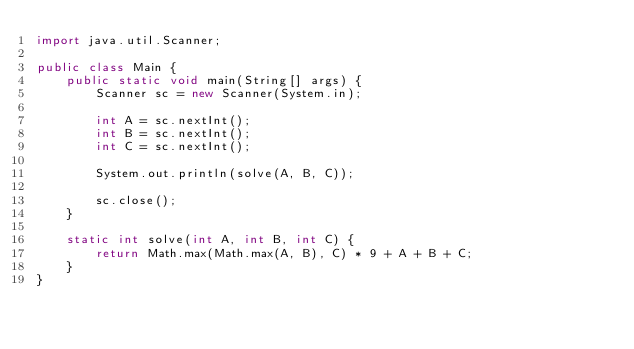Convert code to text. <code><loc_0><loc_0><loc_500><loc_500><_Java_>import java.util.Scanner;

public class Main {
    public static void main(String[] args) {
        Scanner sc = new Scanner(System.in);

        int A = sc.nextInt();
        int B = sc.nextInt();
        int C = sc.nextInt();

        System.out.println(solve(A, B, C));

        sc.close();
    }

    static int solve(int A, int B, int C) {
        return Math.max(Math.max(A, B), C) * 9 + A + B + C;
    }
}</code> 